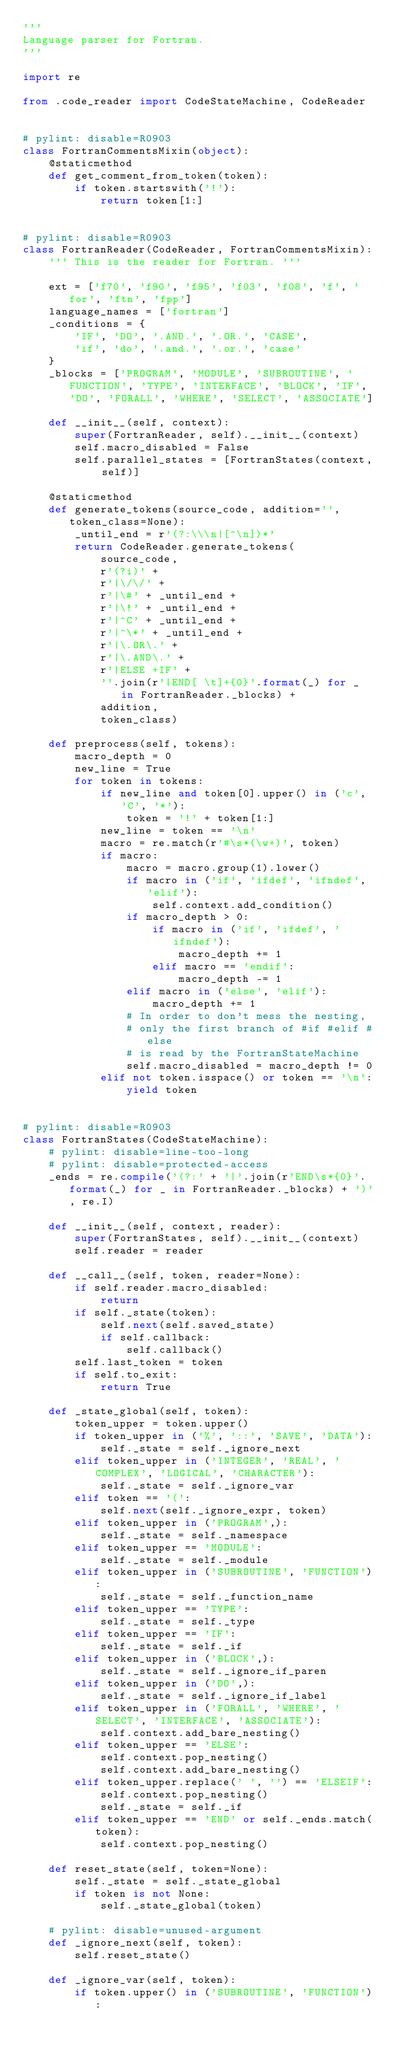<code> <loc_0><loc_0><loc_500><loc_500><_Python_>'''
Language parser for Fortran.
'''

import re

from .code_reader import CodeStateMachine, CodeReader


# pylint: disable=R0903
class FortranCommentsMixin(object):
    @staticmethod
    def get_comment_from_token(token):
        if token.startswith('!'):
            return token[1:]


# pylint: disable=R0903
class FortranReader(CodeReader, FortranCommentsMixin):
    ''' This is the reader for Fortran. '''

    ext = ['f70', 'f90', 'f95', 'f03', 'f08', 'f', 'for', 'ftn', 'fpp']
    language_names = ['fortran']
    _conditions = {
        'IF', 'DO', '.AND.', '.OR.', 'CASE',
        'if', 'do', '.and.', '.or.', 'case'
    }
    _blocks = ['PROGRAM', 'MODULE', 'SUBROUTINE', 'FUNCTION', 'TYPE', 'INTERFACE', 'BLOCK', 'IF', 'DO', 'FORALL', 'WHERE', 'SELECT', 'ASSOCIATE']

    def __init__(self, context):
        super(FortranReader, self).__init__(context)
        self.macro_disabled = False
        self.parallel_states = [FortranStates(context, self)]

    @staticmethod
    def generate_tokens(source_code, addition='', token_class=None):
        _until_end = r'(?:\\\n|[^\n])*'
        return CodeReader.generate_tokens(
            source_code,
            r'(?i)' +
            r'|\/\/' +
            r'|\#' + _until_end +
            r'|\!' + _until_end +
            r'|^C' + _until_end +
            r'|^\*' + _until_end +
            r'|\.OR\.' +
            r'|\.AND\.' +
            r'|ELSE +IF' +
            ''.join(r'|END[ \t]+{0}'.format(_) for _ in FortranReader._blocks) +
            addition,
            token_class)

    def preprocess(self, tokens):
        macro_depth = 0
        new_line = True
        for token in tokens:
            if new_line and token[0].upper() in ('c', 'C', '*'):
                token = '!' + token[1:]
            new_line = token == '\n'
            macro = re.match(r'#\s*(\w+)', token)
            if macro:
                macro = macro.group(1).lower()
                if macro in ('if', 'ifdef', 'ifndef', 'elif'):
                    self.context.add_condition()
                if macro_depth > 0:
                    if macro in ('if', 'ifdef', 'ifndef'):
                        macro_depth += 1
                    elif macro == 'endif':
                        macro_depth -= 1
                elif macro in ('else', 'elif'):
                    macro_depth += 1
                # In order to don't mess the nesting,
                # only the first branch of #if #elif #else
                # is read by the FortranStateMachine
                self.macro_disabled = macro_depth != 0
            elif not token.isspace() or token == '\n':
                yield token


# pylint: disable=R0903
class FortranStates(CodeStateMachine):
    # pylint: disable=line-too-long
    # pylint: disable=protected-access
    _ends = re.compile('(?:' + '|'.join(r'END\s*{0}'.format(_) for _ in FortranReader._blocks) + ')', re.I)

    def __init__(self, context, reader):
        super(FortranStates, self).__init__(context)
        self.reader = reader

    def __call__(self, token, reader=None):
        if self.reader.macro_disabled:
            return
        if self._state(token):
            self.next(self.saved_state)
            if self.callback:
                self.callback()
        self.last_token = token
        if self.to_exit:
            return True

    def _state_global(self, token):
        token_upper = token.upper()
        if token_upper in ('%', '::', 'SAVE', 'DATA'):
            self._state = self._ignore_next
        elif token_upper in ('INTEGER', 'REAL', 'COMPLEX', 'LOGICAL', 'CHARACTER'):
            self._state = self._ignore_var
        elif token == '(':
            self.next(self._ignore_expr, token)
        elif token_upper in ('PROGRAM',):
            self._state = self._namespace
        elif token_upper == 'MODULE':
            self._state = self._module
        elif token_upper in ('SUBROUTINE', 'FUNCTION'):
            self._state = self._function_name
        elif token_upper == 'TYPE':
            self._state = self._type
        elif token_upper == 'IF':
            self._state = self._if
        elif token_upper in ('BLOCK',):
            self._state = self._ignore_if_paren
        elif token_upper in ('DO',):
            self._state = self._ignore_if_label
        elif token_upper in ('FORALL', 'WHERE', 'SELECT', 'INTERFACE', 'ASSOCIATE'):
            self.context.add_bare_nesting()
        elif token_upper == 'ELSE':
            self.context.pop_nesting()
            self.context.add_bare_nesting()
        elif token_upper.replace(' ', '') == 'ELSEIF':
            self.context.pop_nesting()
            self._state = self._if
        elif token_upper == 'END' or self._ends.match(token):
            self.context.pop_nesting()

    def reset_state(self, token=None):
        self._state = self._state_global
        if token is not None:
            self._state_global(token)

    # pylint: disable=unused-argument
    def _ignore_next(self, token):
        self.reset_state()

    def _ignore_var(self, token):
        if token.upper() in ('SUBROUTINE', 'FUNCTION'):</code> 